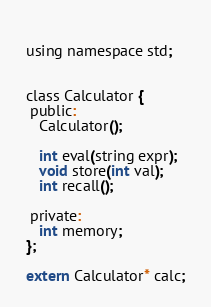<code> <loc_0><loc_0><loc_500><loc_500><_C_> 
using namespace std;


class Calculator {
 public:
   Calculator();

   int eval(string expr);
   void store(int val);
   int recall();

 private:
   int memory;
};

extern Calculator* calc;


</code> 